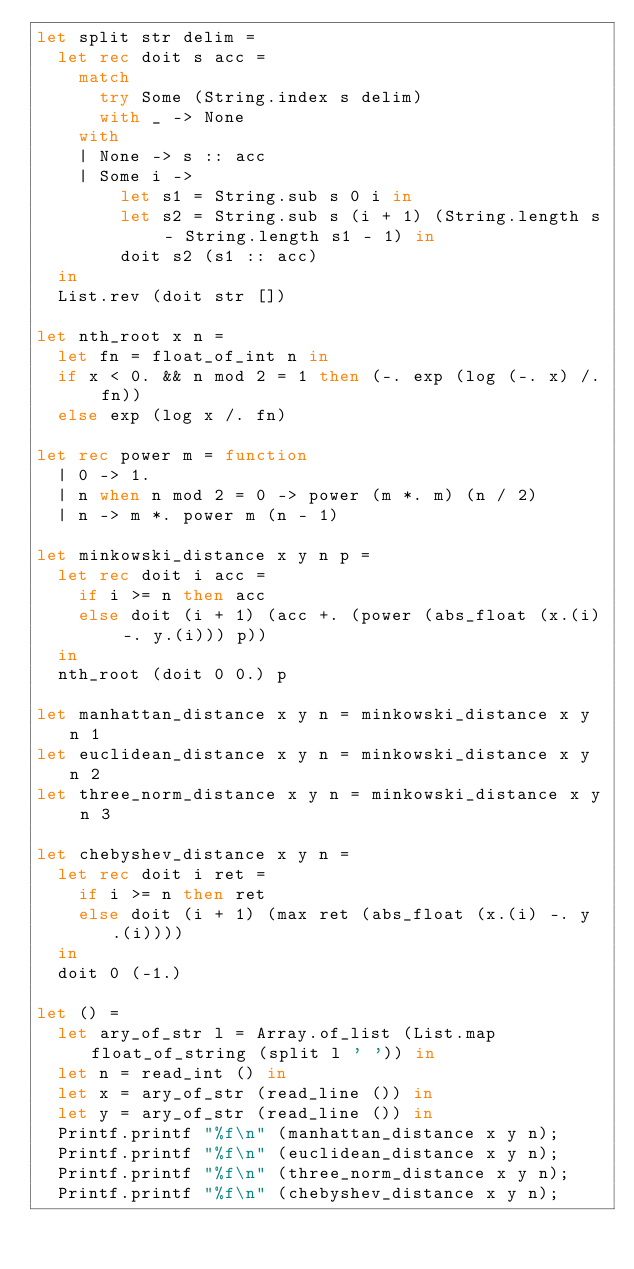<code> <loc_0><loc_0><loc_500><loc_500><_OCaml_>let split str delim =
  let rec doit s acc =
    match 
      try Some (String.index s delim)
      with _ -> None
    with
    | None -> s :: acc
    | Some i ->
        let s1 = String.sub s 0 i in
        let s2 = String.sub s (i + 1) (String.length s - String.length s1 - 1) in
        doit s2 (s1 :: acc)
  in
  List.rev (doit str [])

let nth_root x n =
  let fn = float_of_int n in
  if x < 0. && n mod 2 = 1 then (-. exp (log (-. x) /. fn))
  else exp (log x /. fn)

let rec power m = function
  | 0 -> 1.
  | n when n mod 2 = 0 -> power (m *. m) (n / 2)
  | n -> m *. power m (n - 1)

let minkowski_distance x y n p =
  let rec doit i acc =
    if i >= n then acc
    else doit (i + 1) (acc +. (power (abs_float (x.(i) -. y.(i))) p))
  in
  nth_root (doit 0 0.) p

let manhattan_distance x y n = minkowski_distance x y n 1
let euclidean_distance x y n = minkowski_distance x y n 2
let three_norm_distance x y n = minkowski_distance x y n 3

let chebyshev_distance x y n =
  let rec doit i ret =
    if i >= n then ret
    else doit (i + 1) (max ret (abs_float (x.(i) -. y.(i))))
  in
  doit 0 (-1.)

let () =
  let ary_of_str l = Array.of_list (List.map float_of_string (split l ' ')) in
  let n = read_int () in
  let x = ary_of_str (read_line ()) in
  let y = ary_of_str (read_line ()) in
  Printf.printf "%f\n" (manhattan_distance x y n);
  Printf.printf "%f\n" (euclidean_distance x y n);
  Printf.printf "%f\n" (three_norm_distance x y n);
  Printf.printf "%f\n" (chebyshev_distance x y n);</code> 